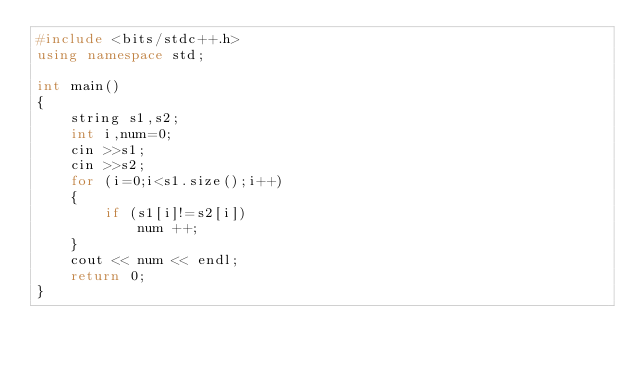Convert code to text. <code><loc_0><loc_0><loc_500><loc_500><_C++_>#include <bits/stdc++.h>
using namespace std;

int main()
{
    string s1,s2;
    int i,num=0;
    cin >>s1;
    cin >>s2;
    for (i=0;i<s1.size();i++)
    {
        if (s1[i]!=s2[i])
            num ++;
    }
    cout << num << endl;
    return 0;
}</code> 